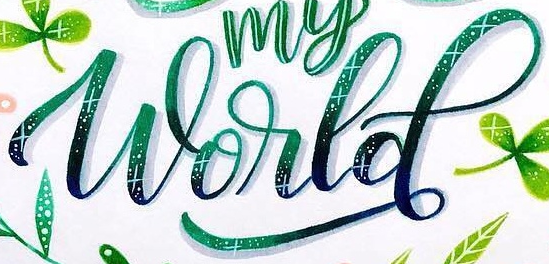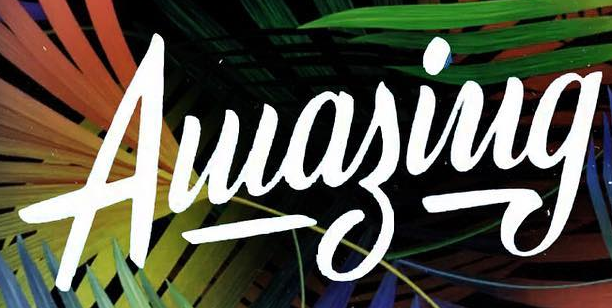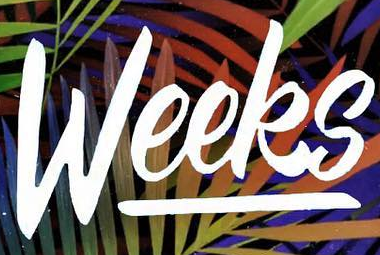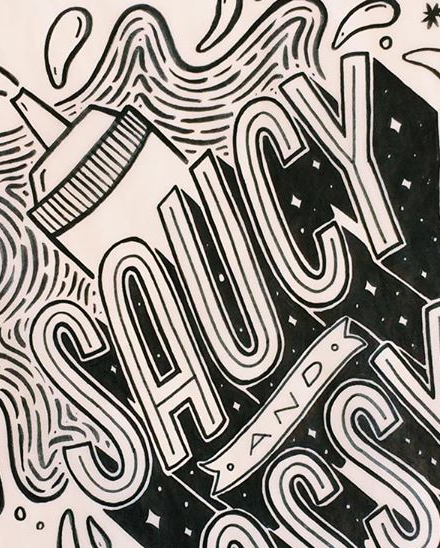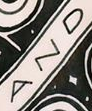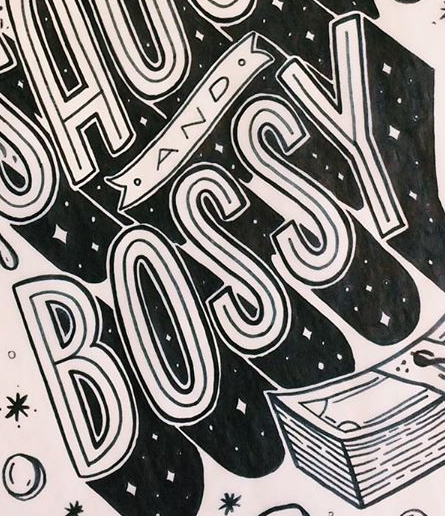What text is displayed in these images sequentially, separated by a semicolon? World; Aluagiug; Weeks; SAUCY; AND; BOSSY 